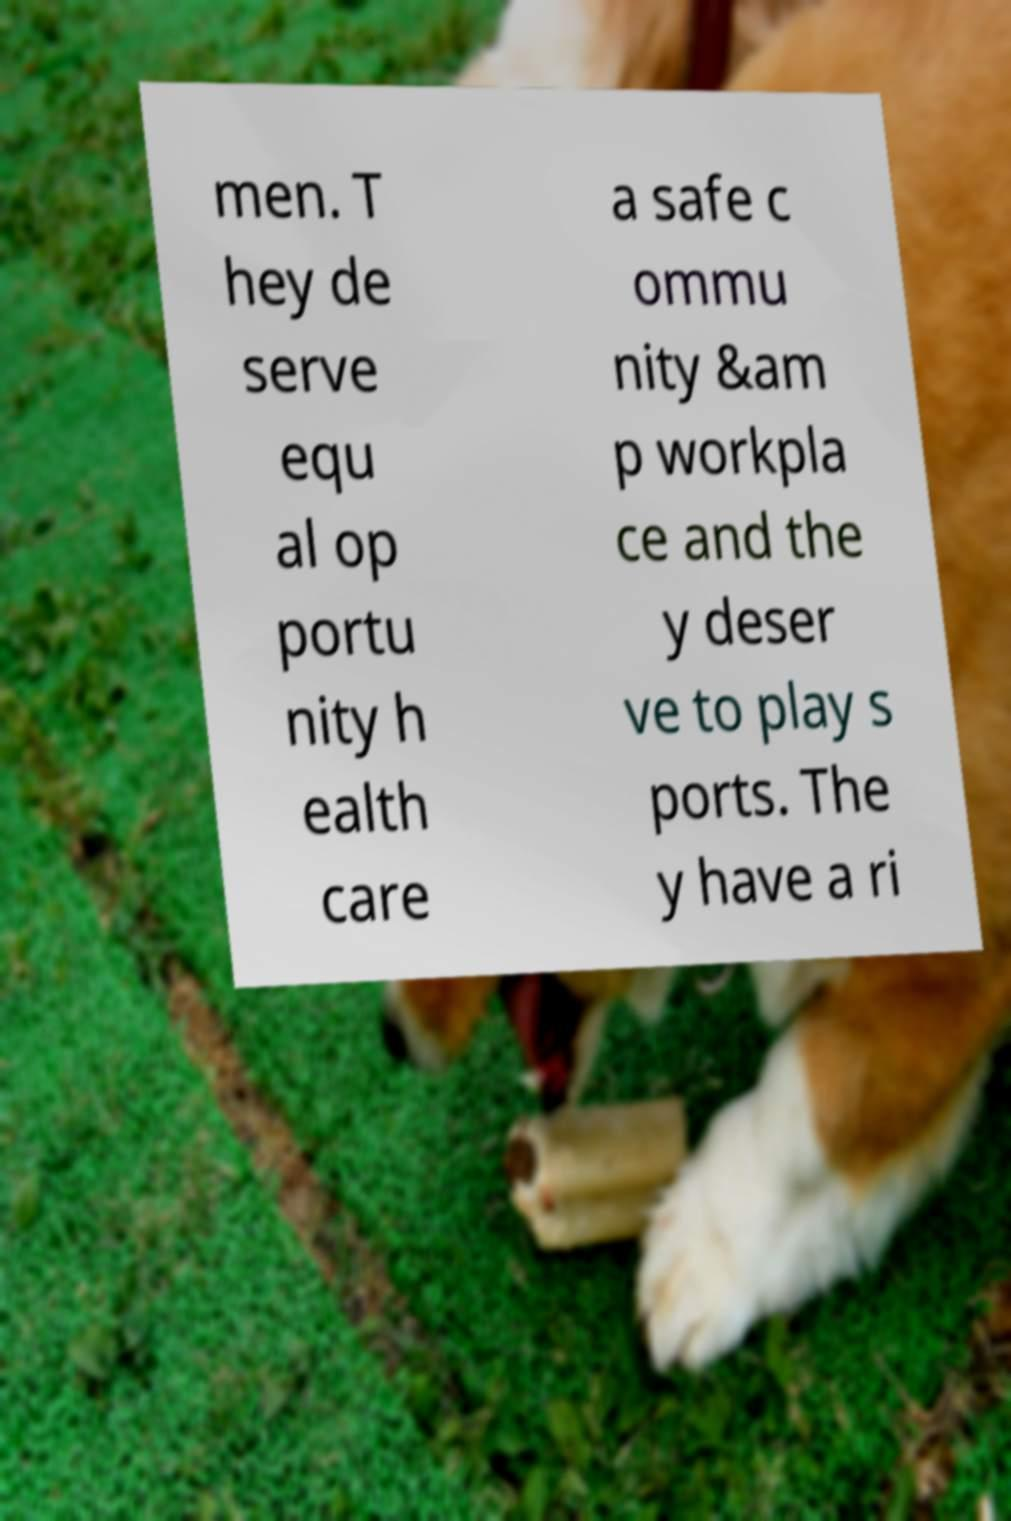For documentation purposes, I need the text within this image transcribed. Could you provide that? men. T hey de serve equ al op portu nity h ealth care a safe c ommu nity &am p workpla ce and the y deser ve to play s ports. The y have a ri 